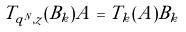<formula> <loc_0><loc_0><loc_500><loc_500>T _ { q ^ { N } , z } ( B _ { k } ) A = T _ { k } ( A ) B _ { k }</formula> 